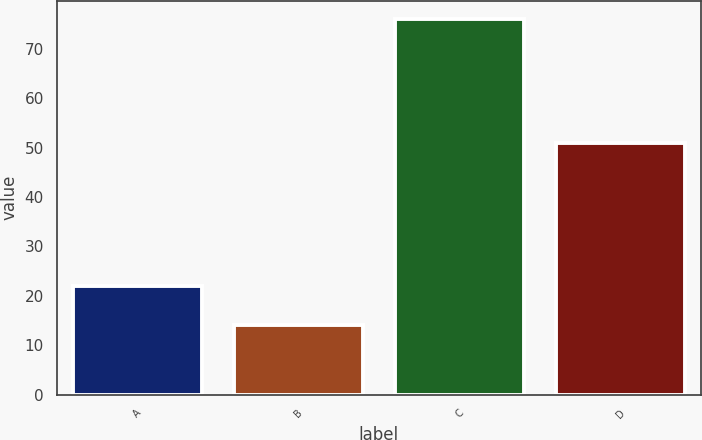<chart> <loc_0><loc_0><loc_500><loc_500><bar_chart><fcel>A<fcel>B<fcel>C<fcel>D<nl><fcel>22<fcel>14<fcel>76<fcel>51<nl></chart> 